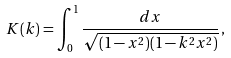<formula> <loc_0><loc_0><loc_500><loc_500>K ( k ) = \int _ { 0 } ^ { 1 } \frac { d x } { \sqrt { ( 1 - x ^ { 2 } ) ( 1 - k ^ { 2 } x ^ { 2 } ) } } \, ,</formula> 